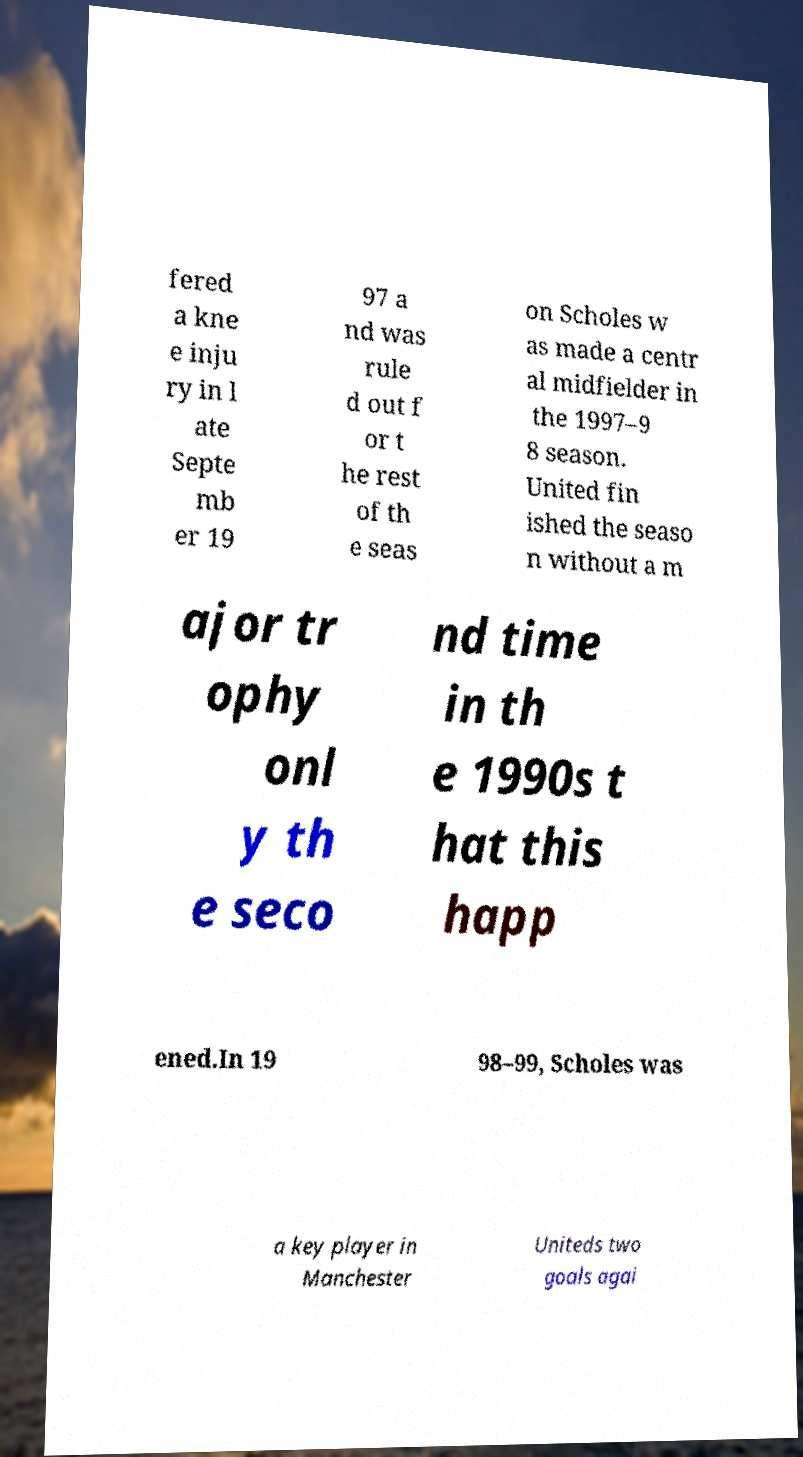I need the written content from this picture converted into text. Can you do that? fered a kne e inju ry in l ate Septe mb er 19 97 a nd was rule d out f or t he rest of th e seas on Scholes w as made a centr al midfielder in the 1997–9 8 season. United fin ished the seaso n without a m ajor tr ophy onl y th e seco nd time in th e 1990s t hat this happ ened.In 19 98–99, Scholes was a key player in Manchester Uniteds two goals agai 